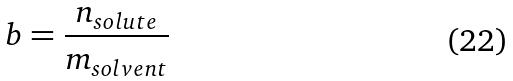Convert formula to latex. <formula><loc_0><loc_0><loc_500><loc_500>b = \frac { n _ { s o l u t e } } { m _ { s o l v e n t } }</formula> 